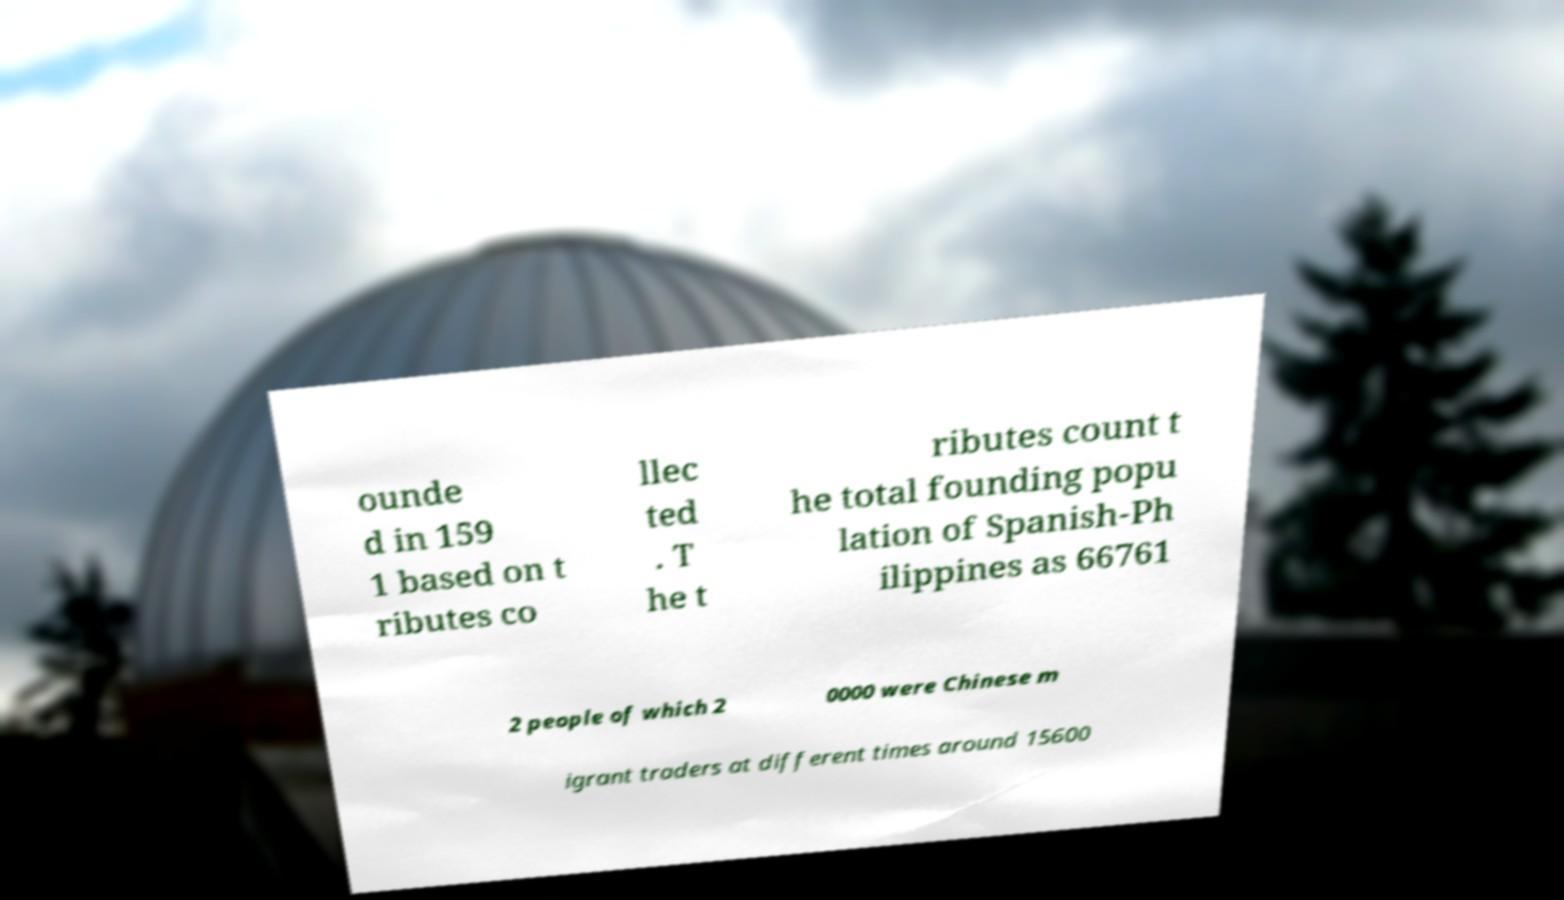What messages or text are displayed in this image? I need them in a readable, typed format. ounde d in 159 1 based on t ributes co llec ted . T he t ributes count t he total founding popu lation of Spanish-Ph ilippines as 66761 2 people of which 2 0000 were Chinese m igrant traders at different times around 15600 